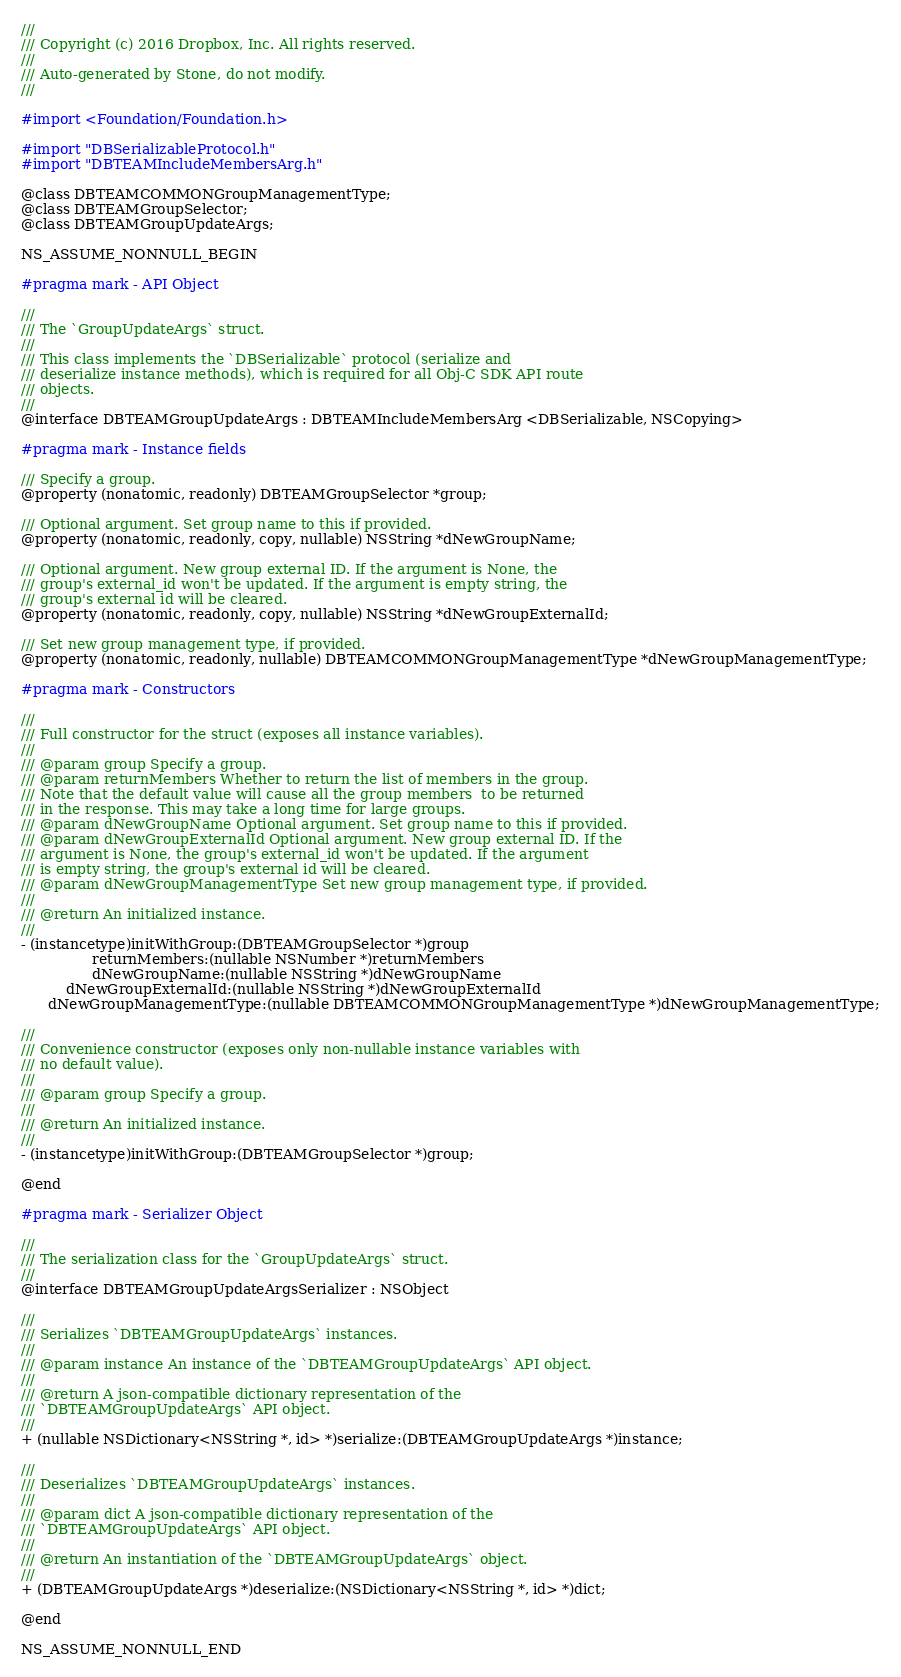Convert code to text. <code><loc_0><loc_0><loc_500><loc_500><_C_>///
/// Copyright (c) 2016 Dropbox, Inc. All rights reserved.
///
/// Auto-generated by Stone, do not modify.
///

#import <Foundation/Foundation.h>

#import "DBSerializableProtocol.h"
#import "DBTEAMIncludeMembersArg.h"

@class DBTEAMCOMMONGroupManagementType;
@class DBTEAMGroupSelector;
@class DBTEAMGroupUpdateArgs;

NS_ASSUME_NONNULL_BEGIN

#pragma mark - API Object

///
/// The `GroupUpdateArgs` struct.
///
/// This class implements the `DBSerializable` protocol (serialize and
/// deserialize instance methods), which is required for all Obj-C SDK API route
/// objects.
///
@interface DBTEAMGroupUpdateArgs : DBTEAMIncludeMembersArg <DBSerializable, NSCopying>

#pragma mark - Instance fields

/// Specify a group.
@property (nonatomic, readonly) DBTEAMGroupSelector *group;

/// Optional argument. Set group name to this if provided.
@property (nonatomic, readonly, copy, nullable) NSString *dNewGroupName;

/// Optional argument. New group external ID. If the argument is None, the
/// group's external_id won't be updated. If the argument is empty string, the
/// group's external id will be cleared.
@property (nonatomic, readonly, copy, nullable) NSString *dNewGroupExternalId;

/// Set new group management type, if provided.
@property (nonatomic, readonly, nullable) DBTEAMCOMMONGroupManagementType *dNewGroupManagementType;

#pragma mark - Constructors

///
/// Full constructor for the struct (exposes all instance variables).
///
/// @param group Specify a group.
/// @param returnMembers Whether to return the list of members in the group.
/// Note that the default value will cause all the group members  to be returned
/// in the response. This may take a long time for large groups.
/// @param dNewGroupName Optional argument. Set group name to this if provided.
/// @param dNewGroupExternalId Optional argument. New group external ID. If the
/// argument is None, the group's external_id won't be updated. If the argument
/// is empty string, the group's external id will be cleared.
/// @param dNewGroupManagementType Set new group management type, if provided.
///
/// @return An initialized instance.
///
- (instancetype)initWithGroup:(DBTEAMGroupSelector *)group
                returnMembers:(nullable NSNumber *)returnMembers
                dNewGroupName:(nullable NSString *)dNewGroupName
          dNewGroupExternalId:(nullable NSString *)dNewGroupExternalId
      dNewGroupManagementType:(nullable DBTEAMCOMMONGroupManagementType *)dNewGroupManagementType;

///
/// Convenience constructor (exposes only non-nullable instance variables with
/// no default value).
///
/// @param group Specify a group.
///
/// @return An initialized instance.
///
- (instancetype)initWithGroup:(DBTEAMGroupSelector *)group;

@end

#pragma mark - Serializer Object

///
/// The serialization class for the `GroupUpdateArgs` struct.
///
@interface DBTEAMGroupUpdateArgsSerializer : NSObject

///
/// Serializes `DBTEAMGroupUpdateArgs` instances.
///
/// @param instance An instance of the `DBTEAMGroupUpdateArgs` API object.
///
/// @return A json-compatible dictionary representation of the
/// `DBTEAMGroupUpdateArgs` API object.
///
+ (nullable NSDictionary<NSString *, id> *)serialize:(DBTEAMGroupUpdateArgs *)instance;

///
/// Deserializes `DBTEAMGroupUpdateArgs` instances.
///
/// @param dict A json-compatible dictionary representation of the
/// `DBTEAMGroupUpdateArgs` API object.
///
/// @return An instantiation of the `DBTEAMGroupUpdateArgs` object.
///
+ (DBTEAMGroupUpdateArgs *)deserialize:(NSDictionary<NSString *, id> *)dict;

@end

NS_ASSUME_NONNULL_END
</code> 